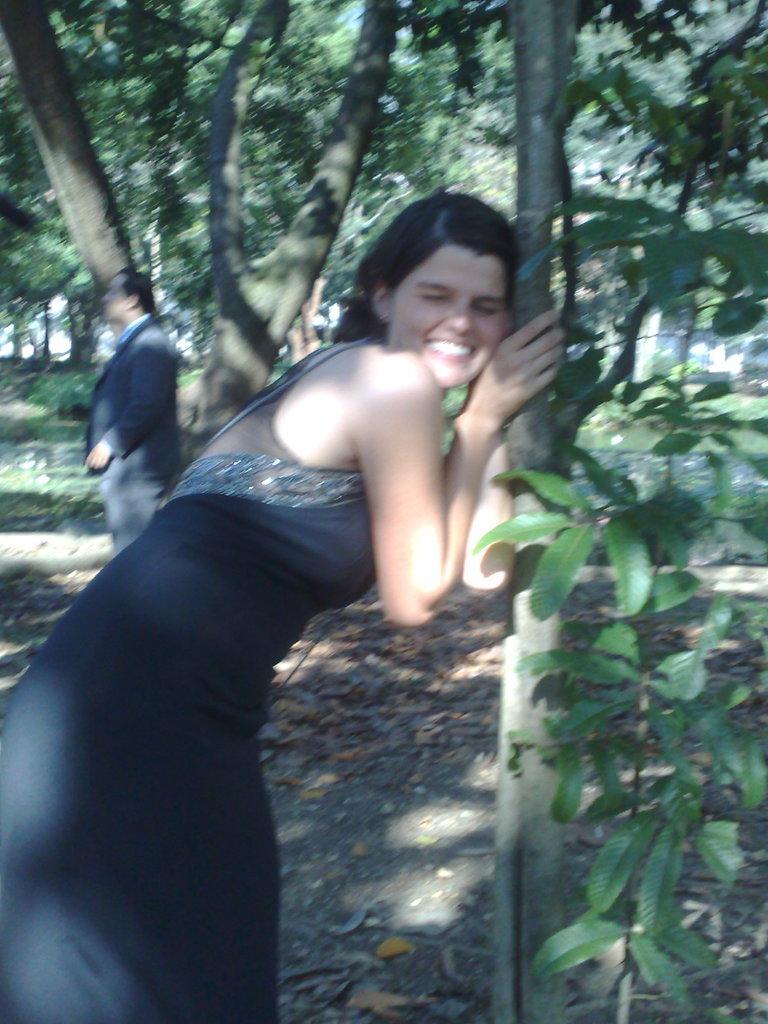Describe this image in one or two sentences. In this image there is ground at the bottom. There is a person wearing a black dress in the foreground. There are leaves on the right corner. There is a person and there are trees in the background. 